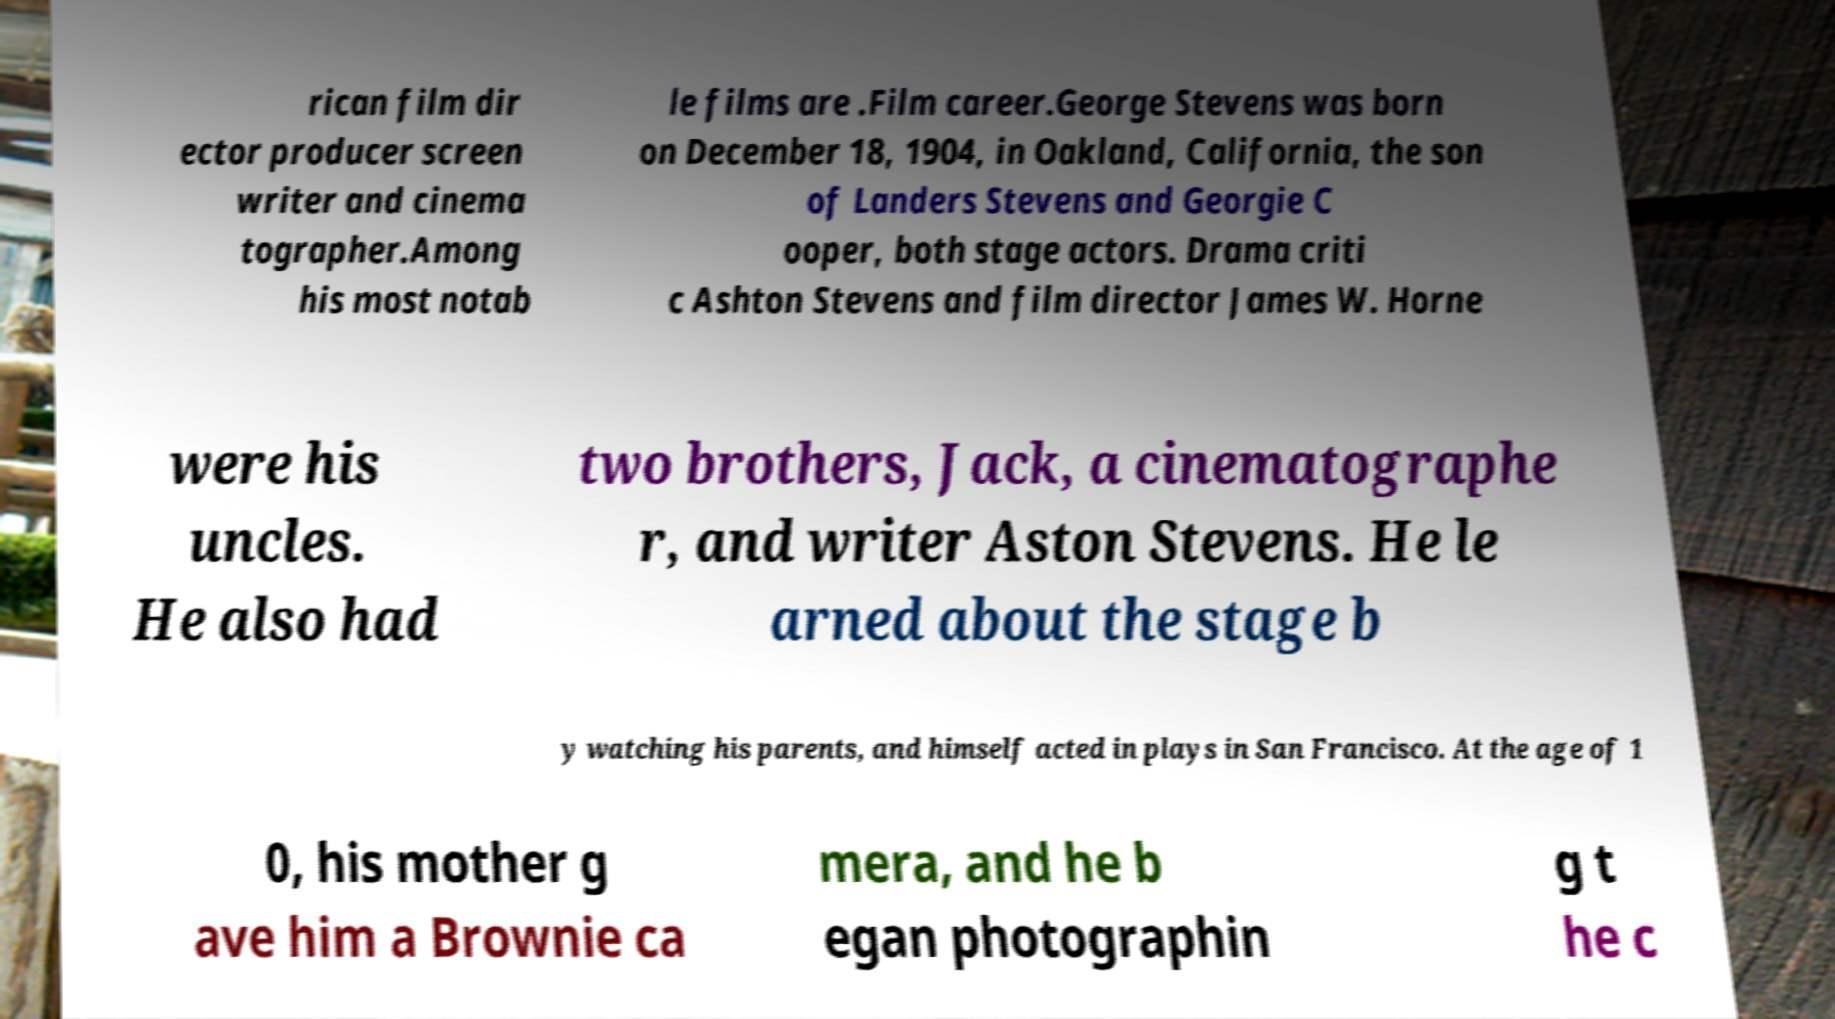Could you assist in decoding the text presented in this image and type it out clearly? rican film dir ector producer screen writer and cinema tographer.Among his most notab le films are .Film career.George Stevens was born on December 18, 1904, in Oakland, California, the son of Landers Stevens and Georgie C ooper, both stage actors. Drama criti c Ashton Stevens and film director James W. Horne were his uncles. He also had two brothers, Jack, a cinematographe r, and writer Aston Stevens. He le arned about the stage b y watching his parents, and himself acted in plays in San Francisco. At the age of 1 0, his mother g ave him a Brownie ca mera, and he b egan photographin g t he c 